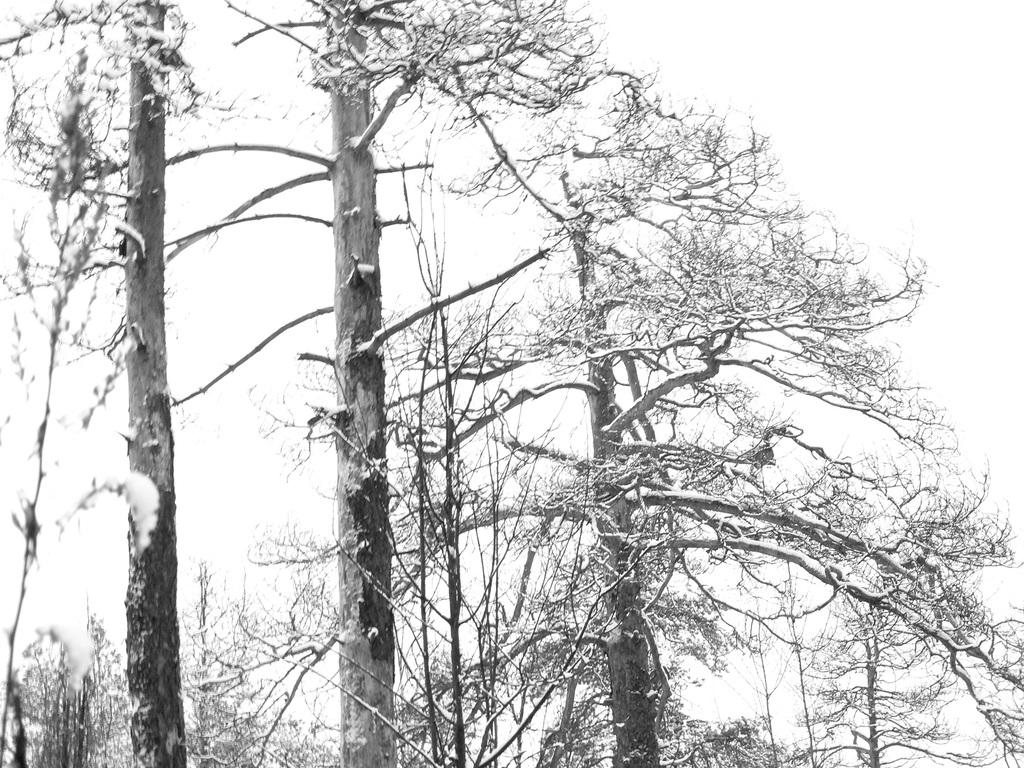What is the color scheme of the image? The image is black and white. What can be seen in the center of the image? There are trees in the center of the image. What color is the background of the image? The background of the image is white. What type of mine can be seen in the image? There is no mine present in the image; it features trees in the center and a white background. What type of silk is draped over the trees in the image? There is no silk present in the image; it only features trees and a white background. 